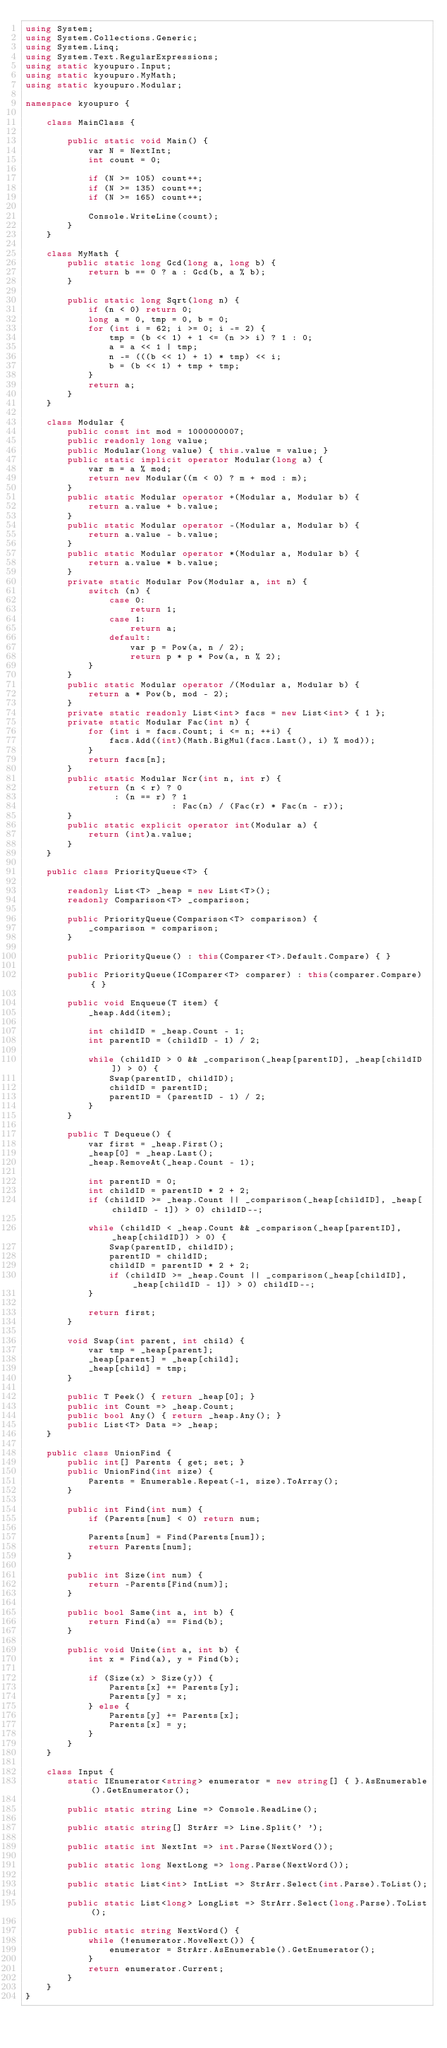<code> <loc_0><loc_0><loc_500><loc_500><_C#_>using System;
using System.Collections.Generic;
using System.Linq;
using System.Text.RegularExpressions;
using static kyoupuro.Input;
using static kyoupuro.MyMath;
using static kyoupuro.Modular;

namespace kyoupuro {

    class MainClass {

        public static void Main() {
            var N = NextInt;
            int count = 0;

            if (N >= 105) count++;
            if (N >= 135) count++;
            if (N >= 165) count++;

            Console.WriteLine(count);
        }
    }

    class MyMath {
        public static long Gcd(long a, long b) {
            return b == 0 ? a : Gcd(b, a % b);
        }

        public static long Sqrt(long n) {
            if (n < 0) return 0;
            long a = 0, tmp = 0, b = 0;
            for (int i = 62; i >= 0; i -= 2) {
                tmp = (b << 1) + 1 <= (n >> i) ? 1 : 0;
                a = a << 1 | tmp;
                n -= (((b << 1) + 1) * tmp) << i;
                b = (b << 1) + tmp + tmp;
            }
            return a;
        }
    }

    class Modular {
        public const int mod = 1000000007;
        public readonly long value;
        public Modular(long value) { this.value = value; }
        public static implicit operator Modular(long a) {
            var m = a % mod;
            return new Modular((m < 0) ? m + mod : m);
        }
        public static Modular operator +(Modular a, Modular b) {
            return a.value + b.value;
        }
        public static Modular operator -(Modular a, Modular b) {
            return a.value - b.value;
        }
        public static Modular operator *(Modular a, Modular b) {
            return a.value * b.value;
        }
        private static Modular Pow(Modular a, int n) {
            switch (n) {
                case 0:
                    return 1;
                case 1:
                    return a;
                default:
                    var p = Pow(a, n / 2);
                    return p * p * Pow(a, n % 2);
            }
        }
        public static Modular operator /(Modular a, Modular b) {
            return a * Pow(b, mod - 2);
        }
        private static readonly List<int> facs = new List<int> { 1 };
        private static Modular Fac(int n) {
            for (int i = facs.Count; i <= n; ++i) {
                facs.Add((int)(Math.BigMul(facs.Last(), i) % mod));
            }
            return facs[n];
        }
        public static Modular Ncr(int n, int r) {
            return (n < r) ? 0
                 : (n == r) ? 1
                            : Fac(n) / (Fac(r) * Fac(n - r));
        }
        public static explicit operator int(Modular a) {
            return (int)a.value;
        }
    }

    public class PriorityQueue<T> {

        readonly List<T> _heap = new List<T>();
        readonly Comparison<T> _comparison;

        public PriorityQueue(Comparison<T> comparison) {
            _comparison = comparison;
        }

        public PriorityQueue() : this(Comparer<T>.Default.Compare) { }

        public PriorityQueue(IComparer<T> comparer) : this(comparer.Compare) { }

        public void Enqueue(T item) {
            _heap.Add(item);

            int childID = _heap.Count - 1;
            int parentID = (childID - 1) / 2;

            while (childID > 0 && _comparison(_heap[parentID], _heap[childID]) > 0) {
                Swap(parentID, childID);
                childID = parentID;
                parentID = (parentID - 1) / 2;
            }
        }

        public T Dequeue() {
            var first = _heap.First();
            _heap[0] = _heap.Last();
            _heap.RemoveAt(_heap.Count - 1);

            int parentID = 0;
            int childID = parentID * 2 + 2;
            if (childID >= _heap.Count || _comparison(_heap[childID], _heap[childID - 1]) > 0) childID--;

            while (childID < _heap.Count && _comparison(_heap[parentID], _heap[childID]) > 0) {
                Swap(parentID, childID);
                parentID = childID;
                childID = parentID * 2 + 2;
                if (childID >= _heap.Count || _comparison(_heap[childID], _heap[childID - 1]) > 0) childID--;
            }

            return first;
        }

        void Swap(int parent, int child) {
            var tmp = _heap[parent];
            _heap[parent] = _heap[child];
            _heap[child] = tmp;
        }

        public T Peek() { return _heap[0]; }
        public int Count => _heap.Count;
        public bool Any() { return _heap.Any(); }
        public List<T> Data => _heap;
    }

    public class UnionFind {
        public int[] Parents { get; set; }
        public UnionFind(int size) {
            Parents = Enumerable.Repeat(-1, size).ToArray();
        }

        public int Find(int num) {
            if (Parents[num] < 0) return num;

            Parents[num] = Find(Parents[num]);
            return Parents[num];
        }

        public int Size(int num) {
            return -Parents[Find(num)];
        }

        public bool Same(int a, int b) {
            return Find(a) == Find(b);
        }

        public void Unite(int a, int b) {
            int x = Find(a), y = Find(b);

            if (Size(x) > Size(y)) {
                Parents[x] += Parents[y];
                Parents[y] = x;
            } else {
                Parents[y] += Parents[x];
                Parents[x] = y;
            }
        }
    }

    class Input {
        static IEnumerator<string> enumerator = new string[] { }.AsEnumerable().GetEnumerator();

        public static string Line => Console.ReadLine();

        public static string[] StrArr => Line.Split(' ');

        public static int NextInt => int.Parse(NextWord());

        public static long NextLong => long.Parse(NextWord());

        public static List<int> IntList => StrArr.Select(int.Parse).ToList();

        public static List<long> LongList => StrArr.Select(long.Parse).ToList();

        public static string NextWord() {
            while (!enumerator.MoveNext()) {
                enumerator = StrArr.AsEnumerable().GetEnumerator();
            }
            return enumerator.Current;
        }
    }
}</code> 